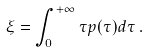<formula> <loc_0><loc_0><loc_500><loc_500>\xi = \int _ { 0 } ^ { + \infty } \tau p ( \tau ) d \tau \, .</formula> 